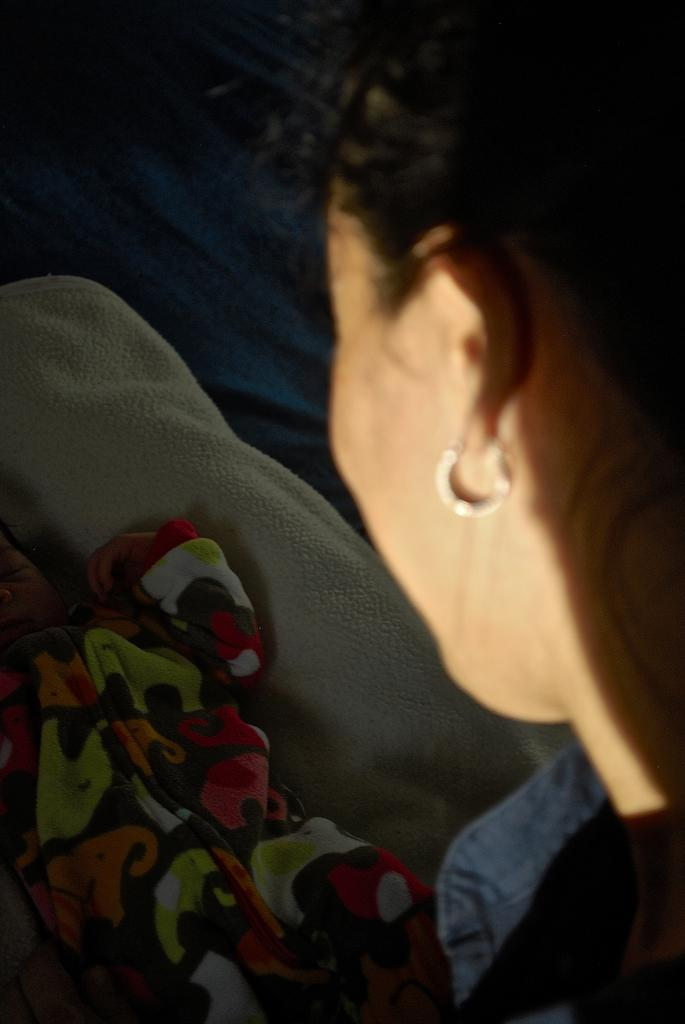Who is present in the image? There is a woman in the image. Can you describe the woman's appearance? The woman is wearing an earring on the right side. What else can be seen in the image? There is a baby visible in the image. How is the baby positioned in the image? The baby is on a white towel. Can you tell me how many houses are visible in the image? There are no houses visible in the image. What type of boat is the woman using to jump in the image? There is no boat or jumping activity present in the image. 